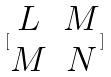Convert formula to latex. <formula><loc_0><loc_0><loc_500><loc_500>[ \begin{matrix} L & M \\ M & N \end{matrix} ]</formula> 